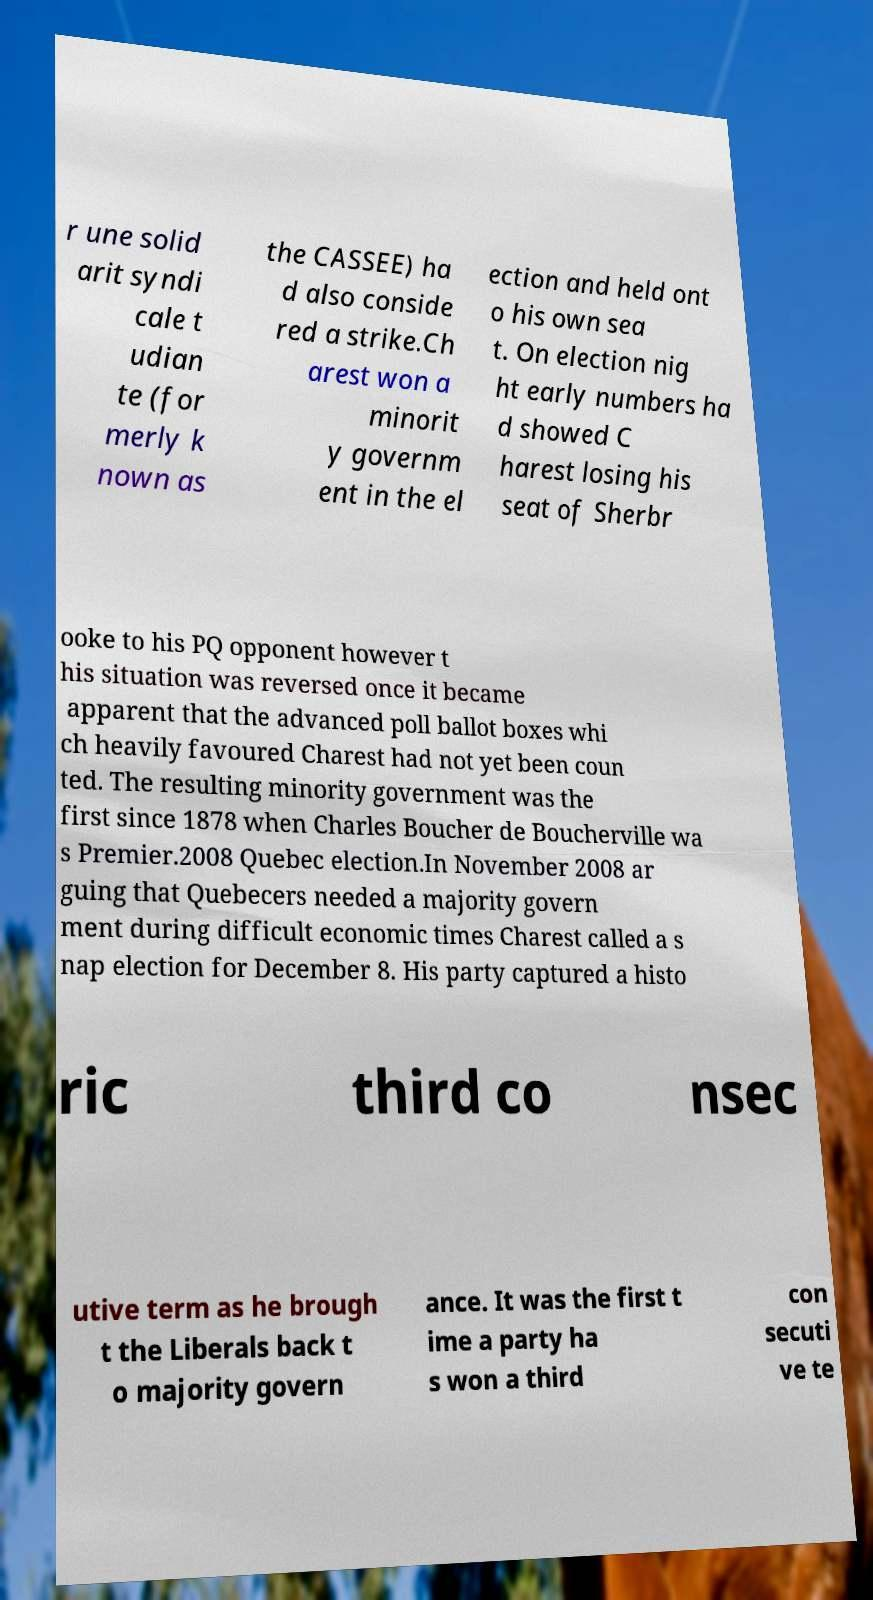There's text embedded in this image that I need extracted. Can you transcribe it verbatim? r une solid arit syndi cale t udian te (for merly k nown as the CASSEE) ha d also conside red a strike.Ch arest won a minorit y governm ent in the el ection and held ont o his own sea t. On election nig ht early numbers ha d showed C harest losing his seat of Sherbr ooke to his PQ opponent however t his situation was reversed once it became apparent that the advanced poll ballot boxes whi ch heavily favoured Charest had not yet been coun ted. The resulting minority government was the first since 1878 when Charles Boucher de Boucherville wa s Premier.2008 Quebec election.In November 2008 ar guing that Quebecers needed a majority govern ment during difficult economic times Charest called a s nap election for December 8. His party captured a histo ric third co nsec utive term as he brough t the Liberals back t o majority govern ance. It was the first t ime a party ha s won a third con secuti ve te 